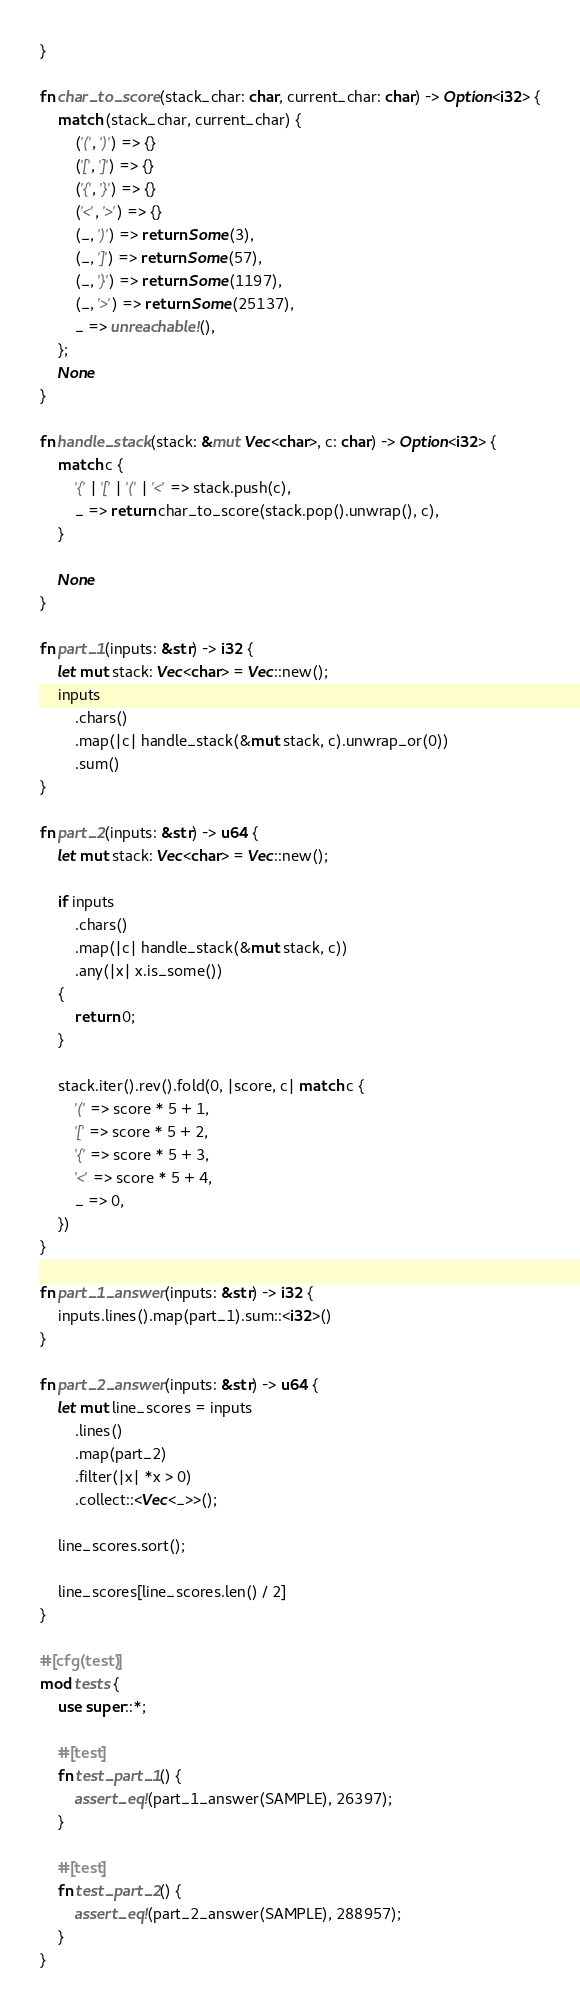<code> <loc_0><loc_0><loc_500><loc_500><_Rust_>}

fn char_to_score(stack_char: char, current_char: char) -> Option<i32> {
    match (stack_char, current_char) {
        ('(', ')') => {}
        ('[', ']') => {}
        ('{', '}') => {}
        ('<', '>') => {}
        (_, ')') => return Some(3),
        (_, ']') => return Some(57),
        (_, '}') => return Some(1197),
        (_, '>') => return Some(25137),
        _ => unreachable!(),
    };
    None
}

fn handle_stack(stack: &mut Vec<char>, c: char) -> Option<i32> {
    match c {
        '{' | '[' | '(' | '<' => stack.push(c),
        _ => return char_to_score(stack.pop().unwrap(), c),
    }

    None
}

fn part_1(inputs: &str) -> i32 {
    let mut stack: Vec<char> = Vec::new();
    inputs
        .chars()
        .map(|c| handle_stack(&mut stack, c).unwrap_or(0))
        .sum()
}

fn part_2(inputs: &str) -> u64 {
    let mut stack: Vec<char> = Vec::new();

    if inputs
        .chars()
        .map(|c| handle_stack(&mut stack, c))
        .any(|x| x.is_some())
    {
        return 0;
    }

    stack.iter().rev().fold(0, |score, c| match c {
        '(' => score * 5 + 1,
        '[' => score * 5 + 2,
        '{' => score * 5 + 3,
        '<' => score * 5 + 4,
        _ => 0,
    })
}

fn part_1_answer(inputs: &str) -> i32 {
    inputs.lines().map(part_1).sum::<i32>()
}

fn part_2_answer(inputs: &str) -> u64 {
    let mut line_scores = inputs
        .lines()
        .map(part_2)
        .filter(|x| *x > 0)
        .collect::<Vec<_>>();

    line_scores.sort();

    line_scores[line_scores.len() / 2]
}

#[cfg(test)]
mod tests {
    use super::*;

    #[test]
    fn test_part_1() {
        assert_eq!(part_1_answer(SAMPLE), 26397);
    }

    #[test]
    fn test_part_2() {
        assert_eq!(part_2_answer(SAMPLE), 288957);
    }
}
</code> 